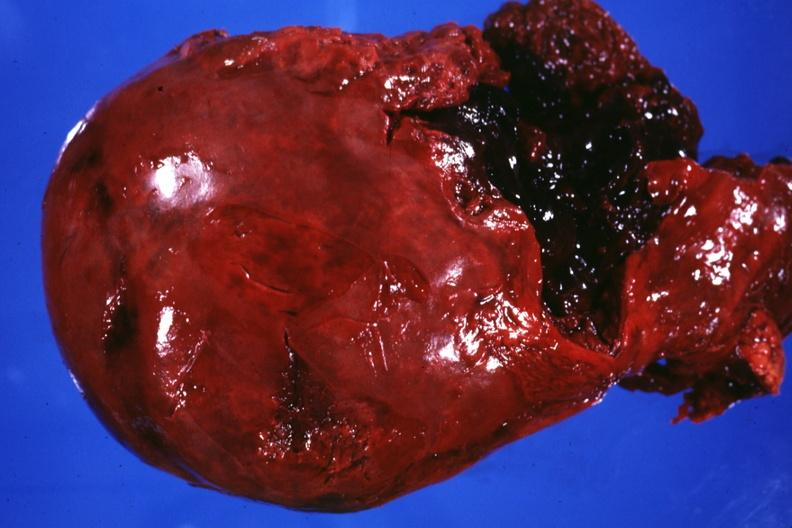what is present?
Answer the question using a single word or phrase. Liver 